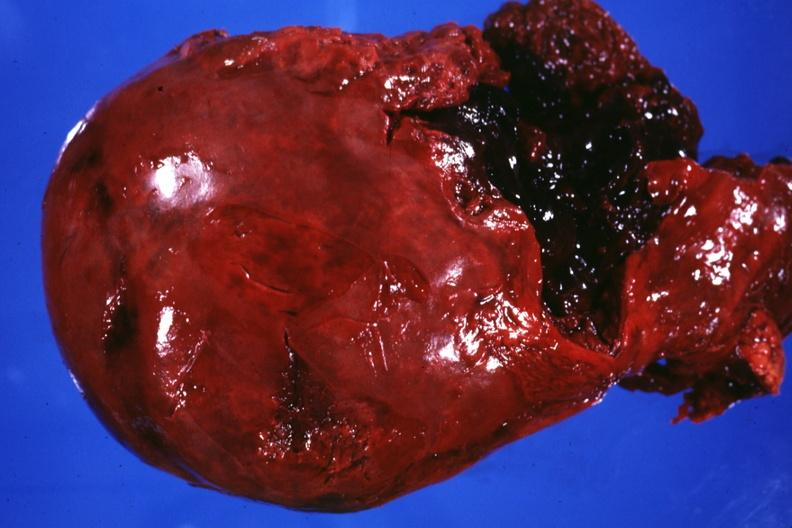what is present?
Answer the question using a single word or phrase. Liver 